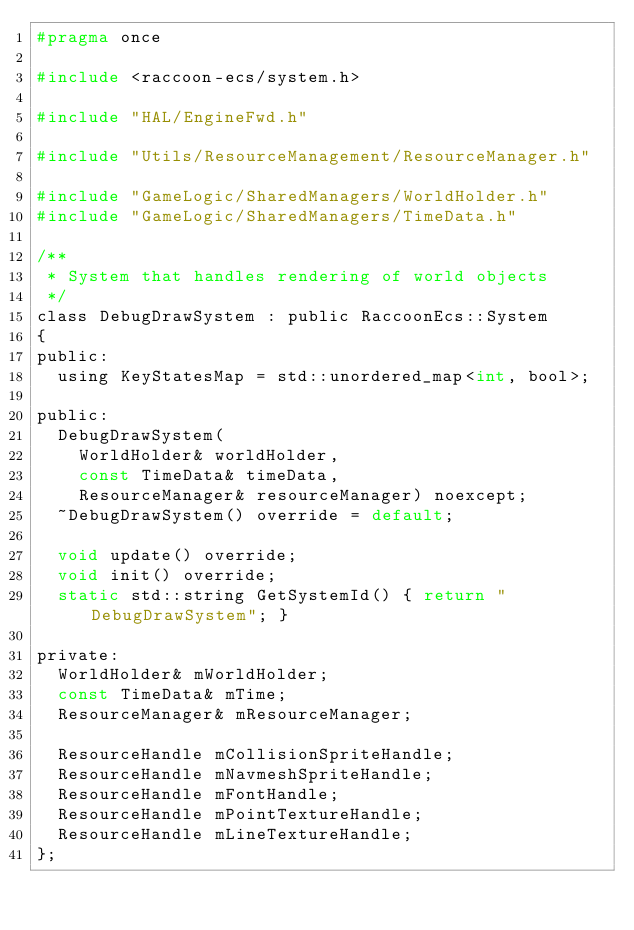Convert code to text. <code><loc_0><loc_0><loc_500><loc_500><_C_>#pragma once

#include <raccoon-ecs/system.h>

#include "HAL/EngineFwd.h"

#include "Utils/ResourceManagement/ResourceManager.h"

#include "GameLogic/SharedManagers/WorldHolder.h"
#include "GameLogic/SharedManagers/TimeData.h"

/**
 * System that handles rendering of world objects
 */
class DebugDrawSystem : public RaccoonEcs::System
{
public:
	using KeyStatesMap = std::unordered_map<int, bool>;

public:
	DebugDrawSystem(
		WorldHolder& worldHolder,
		const TimeData& timeData,
		ResourceManager& resourceManager) noexcept;
	~DebugDrawSystem() override = default;

	void update() override;
	void init() override;
	static std::string GetSystemId() { return "DebugDrawSystem"; }

private:
	WorldHolder& mWorldHolder;
	const TimeData& mTime;
	ResourceManager& mResourceManager;

	ResourceHandle mCollisionSpriteHandle;
	ResourceHandle mNavmeshSpriteHandle;
	ResourceHandle mFontHandle;
	ResourceHandle mPointTextureHandle;
	ResourceHandle mLineTextureHandle;
};
</code> 